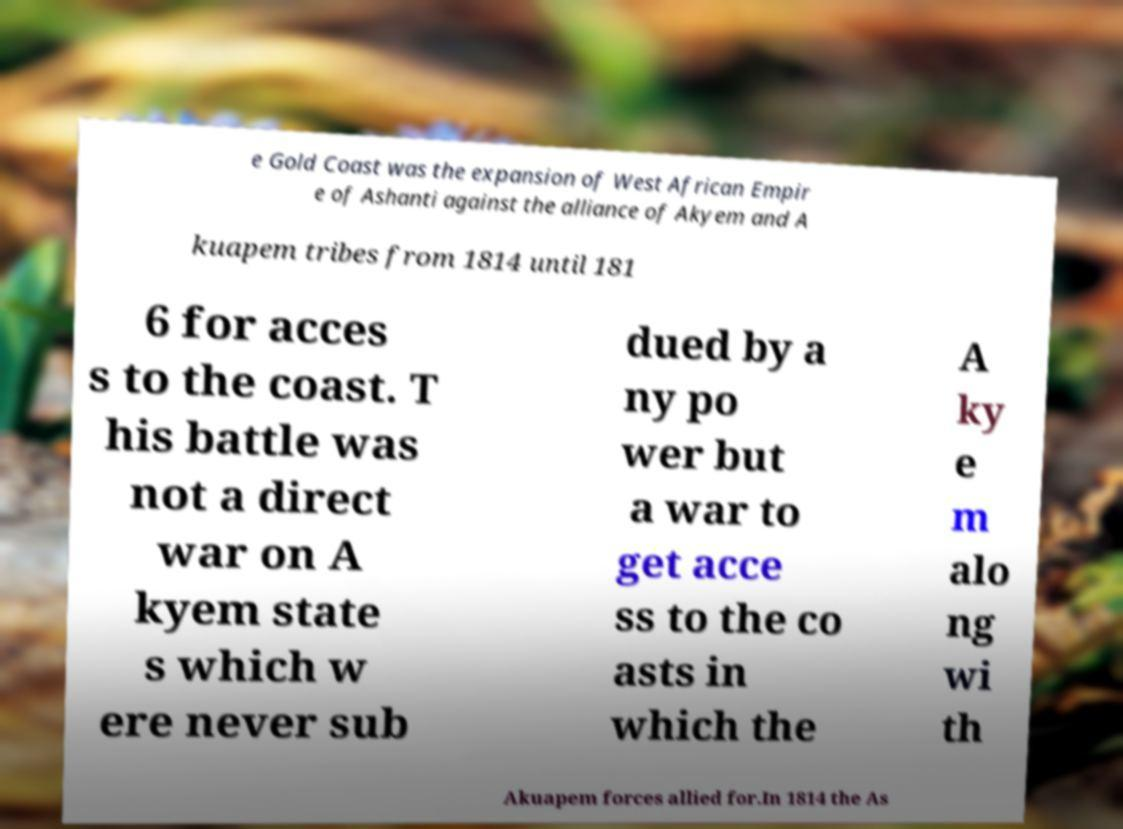For documentation purposes, I need the text within this image transcribed. Could you provide that? e Gold Coast was the expansion of West African Empir e of Ashanti against the alliance of Akyem and A kuapem tribes from 1814 until 181 6 for acces s to the coast. T his battle was not a direct war on A kyem state s which w ere never sub dued by a ny po wer but a war to get acce ss to the co asts in which the A ky e m alo ng wi th Akuapem forces allied for.In 1814 the As 